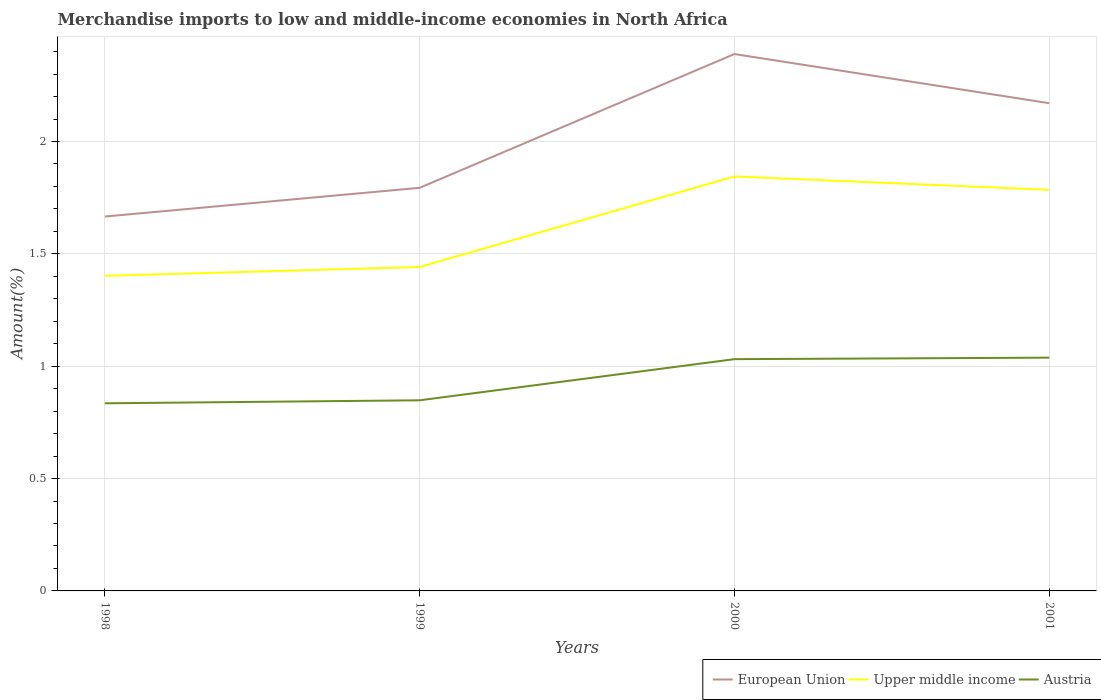Across all years, what is the maximum percentage of amount earned from merchandise imports in Upper middle income?
Your response must be concise. 1.4. What is the total percentage of amount earned from merchandise imports in Austria in the graph?
Provide a short and direct response. -0.18. What is the difference between the highest and the second highest percentage of amount earned from merchandise imports in Upper middle income?
Keep it short and to the point. 0.44. Is the percentage of amount earned from merchandise imports in European Union strictly greater than the percentage of amount earned from merchandise imports in Upper middle income over the years?
Provide a short and direct response. No. How many lines are there?
Offer a very short reply. 3. What is the difference between two consecutive major ticks on the Y-axis?
Give a very brief answer. 0.5. Does the graph contain any zero values?
Your answer should be very brief. No. Does the graph contain grids?
Keep it short and to the point. Yes. Where does the legend appear in the graph?
Keep it short and to the point. Bottom right. How many legend labels are there?
Make the answer very short. 3. What is the title of the graph?
Make the answer very short. Merchandise imports to low and middle-income economies in North Africa. What is the label or title of the Y-axis?
Keep it short and to the point. Amount(%). What is the Amount(%) of European Union in 1998?
Give a very brief answer. 1.67. What is the Amount(%) of Upper middle income in 1998?
Ensure brevity in your answer.  1.4. What is the Amount(%) in Austria in 1998?
Offer a terse response. 0.83. What is the Amount(%) in European Union in 1999?
Provide a succinct answer. 1.79. What is the Amount(%) of Upper middle income in 1999?
Give a very brief answer. 1.44. What is the Amount(%) of Austria in 1999?
Your answer should be compact. 0.85. What is the Amount(%) of European Union in 2000?
Your response must be concise. 2.39. What is the Amount(%) of Upper middle income in 2000?
Keep it short and to the point. 1.84. What is the Amount(%) in Austria in 2000?
Make the answer very short. 1.03. What is the Amount(%) of European Union in 2001?
Your answer should be compact. 2.17. What is the Amount(%) of Upper middle income in 2001?
Your answer should be very brief. 1.78. What is the Amount(%) of Austria in 2001?
Make the answer very short. 1.04. Across all years, what is the maximum Amount(%) in European Union?
Make the answer very short. 2.39. Across all years, what is the maximum Amount(%) in Upper middle income?
Your answer should be very brief. 1.84. Across all years, what is the maximum Amount(%) of Austria?
Keep it short and to the point. 1.04. Across all years, what is the minimum Amount(%) in European Union?
Give a very brief answer. 1.67. Across all years, what is the minimum Amount(%) in Upper middle income?
Provide a succinct answer. 1.4. Across all years, what is the minimum Amount(%) in Austria?
Provide a short and direct response. 0.83. What is the total Amount(%) in European Union in the graph?
Your answer should be very brief. 8.02. What is the total Amount(%) of Upper middle income in the graph?
Offer a terse response. 6.47. What is the total Amount(%) of Austria in the graph?
Provide a succinct answer. 3.75. What is the difference between the Amount(%) in European Union in 1998 and that in 1999?
Provide a succinct answer. -0.13. What is the difference between the Amount(%) in Upper middle income in 1998 and that in 1999?
Offer a terse response. -0.04. What is the difference between the Amount(%) in Austria in 1998 and that in 1999?
Make the answer very short. -0.01. What is the difference between the Amount(%) in European Union in 1998 and that in 2000?
Offer a terse response. -0.72. What is the difference between the Amount(%) in Upper middle income in 1998 and that in 2000?
Offer a very short reply. -0.44. What is the difference between the Amount(%) in Austria in 1998 and that in 2000?
Your response must be concise. -0.2. What is the difference between the Amount(%) in European Union in 1998 and that in 2001?
Offer a very short reply. -0.5. What is the difference between the Amount(%) of Upper middle income in 1998 and that in 2001?
Your answer should be compact. -0.38. What is the difference between the Amount(%) in Austria in 1998 and that in 2001?
Offer a terse response. -0.2. What is the difference between the Amount(%) in European Union in 1999 and that in 2000?
Provide a short and direct response. -0.6. What is the difference between the Amount(%) of Upper middle income in 1999 and that in 2000?
Make the answer very short. -0.4. What is the difference between the Amount(%) of Austria in 1999 and that in 2000?
Provide a succinct answer. -0.18. What is the difference between the Amount(%) in European Union in 1999 and that in 2001?
Provide a succinct answer. -0.38. What is the difference between the Amount(%) in Upper middle income in 1999 and that in 2001?
Provide a succinct answer. -0.34. What is the difference between the Amount(%) in Austria in 1999 and that in 2001?
Offer a very short reply. -0.19. What is the difference between the Amount(%) of European Union in 2000 and that in 2001?
Provide a short and direct response. 0.22. What is the difference between the Amount(%) of Upper middle income in 2000 and that in 2001?
Make the answer very short. 0.06. What is the difference between the Amount(%) of Austria in 2000 and that in 2001?
Give a very brief answer. -0.01. What is the difference between the Amount(%) of European Union in 1998 and the Amount(%) of Upper middle income in 1999?
Keep it short and to the point. 0.22. What is the difference between the Amount(%) in European Union in 1998 and the Amount(%) in Austria in 1999?
Your answer should be compact. 0.82. What is the difference between the Amount(%) in Upper middle income in 1998 and the Amount(%) in Austria in 1999?
Provide a succinct answer. 0.55. What is the difference between the Amount(%) of European Union in 1998 and the Amount(%) of Upper middle income in 2000?
Give a very brief answer. -0.18. What is the difference between the Amount(%) in European Union in 1998 and the Amount(%) in Austria in 2000?
Offer a terse response. 0.63. What is the difference between the Amount(%) in Upper middle income in 1998 and the Amount(%) in Austria in 2000?
Your answer should be compact. 0.37. What is the difference between the Amount(%) in European Union in 1998 and the Amount(%) in Upper middle income in 2001?
Keep it short and to the point. -0.12. What is the difference between the Amount(%) of European Union in 1998 and the Amount(%) of Austria in 2001?
Make the answer very short. 0.63. What is the difference between the Amount(%) in Upper middle income in 1998 and the Amount(%) in Austria in 2001?
Provide a short and direct response. 0.36. What is the difference between the Amount(%) in European Union in 1999 and the Amount(%) in Upper middle income in 2000?
Your answer should be compact. -0.05. What is the difference between the Amount(%) of European Union in 1999 and the Amount(%) of Austria in 2000?
Keep it short and to the point. 0.76. What is the difference between the Amount(%) of Upper middle income in 1999 and the Amount(%) of Austria in 2000?
Make the answer very short. 0.41. What is the difference between the Amount(%) in European Union in 1999 and the Amount(%) in Upper middle income in 2001?
Your answer should be very brief. 0.01. What is the difference between the Amount(%) in European Union in 1999 and the Amount(%) in Austria in 2001?
Offer a very short reply. 0.76. What is the difference between the Amount(%) of Upper middle income in 1999 and the Amount(%) of Austria in 2001?
Keep it short and to the point. 0.4. What is the difference between the Amount(%) of European Union in 2000 and the Amount(%) of Upper middle income in 2001?
Your answer should be very brief. 0.6. What is the difference between the Amount(%) in European Union in 2000 and the Amount(%) in Austria in 2001?
Your answer should be very brief. 1.35. What is the difference between the Amount(%) in Upper middle income in 2000 and the Amount(%) in Austria in 2001?
Your answer should be very brief. 0.81. What is the average Amount(%) in European Union per year?
Your response must be concise. 2. What is the average Amount(%) of Upper middle income per year?
Give a very brief answer. 1.62. What is the average Amount(%) in Austria per year?
Your response must be concise. 0.94. In the year 1998, what is the difference between the Amount(%) of European Union and Amount(%) of Upper middle income?
Offer a terse response. 0.26. In the year 1998, what is the difference between the Amount(%) in European Union and Amount(%) in Austria?
Ensure brevity in your answer.  0.83. In the year 1998, what is the difference between the Amount(%) of Upper middle income and Amount(%) of Austria?
Offer a terse response. 0.57. In the year 1999, what is the difference between the Amount(%) of European Union and Amount(%) of Upper middle income?
Keep it short and to the point. 0.35. In the year 1999, what is the difference between the Amount(%) of European Union and Amount(%) of Austria?
Offer a very short reply. 0.95. In the year 1999, what is the difference between the Amount(%) in Upper middle income and Amount(%) in Austria?
Make the answer very short. 0.59. In the year 2000, what is the difference between the Amount(%) of European Union and Amount(%) of Upper middle income?
Ensure brevity in your answer.  0.54. In the year 2000, what is the difference between the Amount(%) of European Union and Amount(%) of Austria?
Your answer should be compact. 1.36. In the year 2000, what is the difference between the Amount(%) in Upper middle income and Amount(%) in Austria?
Ensure brevity in your answer.  0.81. In the year 2001, what is the difference between the Amount(%) in European Union and Amount(%) in Upper middle income?
Your response must be concise. 0.39. In the year 2001, what is the difference between the Amount(%) of European Union and Amount(%) of Austria?
Give a very brief answer. 1.13. In the year 2001, what is the difference between the Amount(%) of Upper middle income and Amount(%) of Austria?
Give a very brief answer. 0.75. What is the ratio of the Amount(%) in European Union in 1998 to that in 1999?
Keep it short and to the point. 0.93. What is the ratio of the Amount(%) in Upper middle income in 1998 to that in 1999?
Ensure brevity in your answer.  0.97. What is the ratio of the Amount(%) in Austria in 1998 to that in 1999?
Your response must be concise. 0.98. What is the ratio of the Amount(%) in European Union in 1998 to that in 2000?
Ensure brevity in your answer.  0.7. What is the ratio of the Amount(%) of Upper middle income in 1998 to that in 2000?
Your answer should be compact. 0.76. What is the ratio of the Amount(%) in Austria in 1998 to that in 2000?
Provide a short and direct response. 0.81. What is the ratio of the Amount(%) in European Union in 1998 to that in 2001?
Ensure brevity in your answer.  0.77. What is the ratio of the Amount(%) of Upper middle income in 1998 to that in 2001?
Your answer should be compact. 0.79. What is the ratio of the Amount(%) in Austria in 1998 to that in 2001?
Give a very brief answer. 0.8. What is the ratio of the Amount(%) in European Union in 1999 to that in 2000?
Offer a terse response. 0.75. What is the ratio of the Amount(%) in Upper middle income in 1999 to that in 2000?
Offer a very short reply. 0.78. What is the ratio of the Amount(%) of Austria in 1999 to that in 2000?
Keep it short and to the point. 0.82. What is the ratio of the Amount(%) of European Union in 1999 to that in 2001?
Give a very brief answer. 0.83. What is the ratio of the Amount(%) in Upper middle income in 1999 to that in 2001?
Make the answer very short. 0.81. What is the ratio of the Amount(%) of Austria in 1999 to that in 2001?
Ensure brevity in your answer.  0.82. What is the ratio of the Amount(%) in European Union in 2000 to that in 2001?
Your response must be concise. 1.1. What is the ratio of the Amount(%) in Upper middle income in 2000 to that in 2001?
Ensure brevity in your answer.  1.03. What is the ratio of the Amount(%) in Austria in 2000 to that in 2001?
Offer a terse response. 0.99. What is the difference between the highest and the second highest Amount(%) in European Union?
Provide a succinct answer. 0.22. What is the difference between the highest and the second highest Amount(%) of Upper middle income?
Provide a short and direct response. 0.06. What is the difference between the highest and the second highest Amount(%) in Austria?
Keep it short and to the point. 0.01. What is the difference between the highest and the lowest Amount(%) in European Union?
Keep it short and to the point. 0.72. What is the difference between the highest and the lowest Amount(%) in Upper middle income?
Your answer should be very brief. 0.44. What is the difference between the highest and the lowest Amount(%) of Austria?
Offer a terse response. 0.2. 